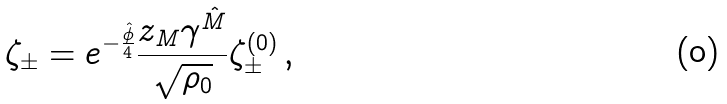<formula> <loc_0><loc_0><loc_500><loc_500>\zeta _ { \pm } = e ^ { - \frac { \hat { \phi } } { 4 } } \frac { z _ { M } \gamma ^ { \hat { M } } } { \sqrt { \rho _ { 0 } } } \zeta _ { \pm } ^ { ( 0 ) } \, ,</formula> 